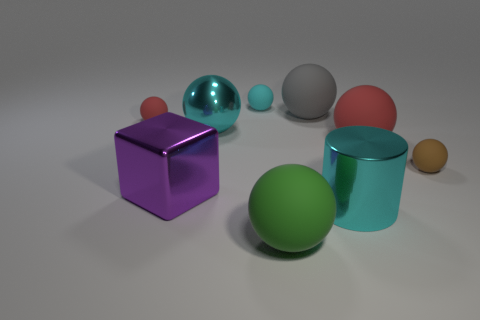Does the large cylinder have the same color as the metallic ball?
Provide a short and direct response. Yes. The big metallic object that is the same color as the cylinder is what shape?
Your answer should be compact. Sphere. There is a big purple object that is made of the same material as the cylinder; what shape is it?
Provide a succinct answer. Cube. What is the material of the small brown object that is the same shape as the big green matte thing?
Your response must be concise. Rubber. What number of other objects are the same size as the green matte sphere?
Your answer should be compact. 5. There is a matte sphere that is the same color as the metal sphere; what size is it?
Your answer should be very brief. Small. There is a big cyan object that is in front of the brown sphere; what shape is it?
Keep it short and to the point. Cylinder. Are there any tiny yellow things made of the same material as the brown ball?
Your answer should be very brief. No. There is a big matte sphere behind the large cyan ball; is it the same color as the big metallic block?
Ensure brevity in your answer.  No. The gray rubber ball is what size?
Your answer should be very brief. Large. 